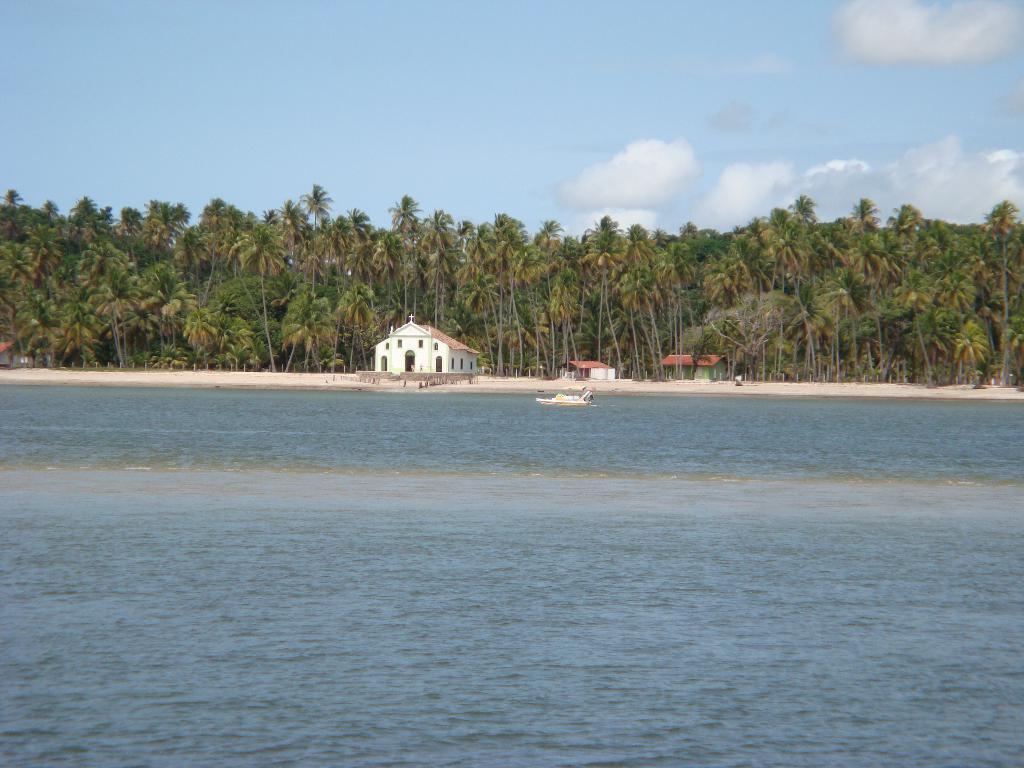Could you give a brief overview of what you see in this image? In this image we can see a river, on the other side of the river we can see houses and trees. 